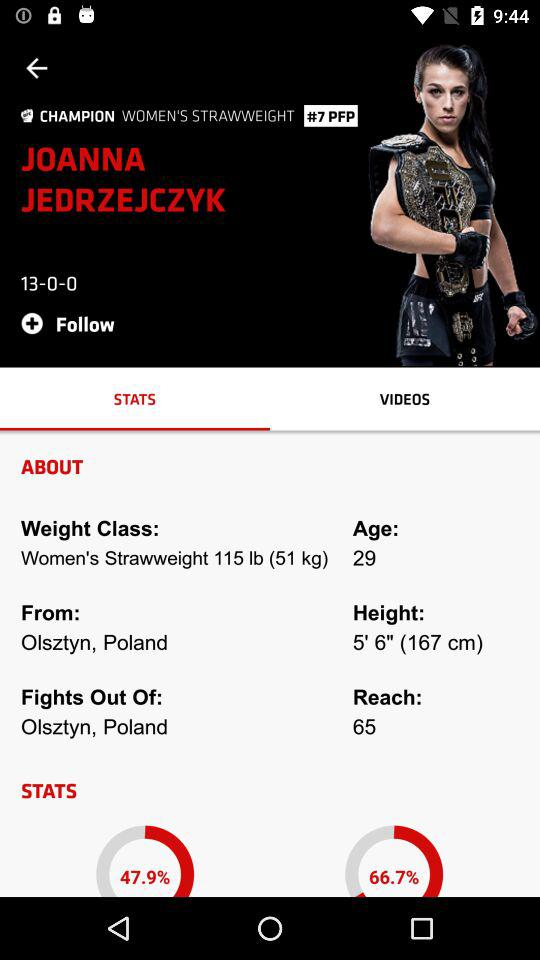How many fight is done out of poland?
When the provided information is insufficient, respond with <no answer>. <no answer> 